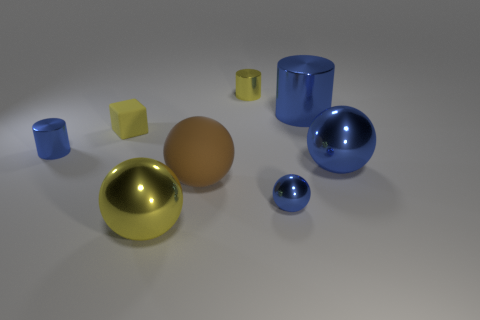Subtract all large blue spheres. How many spheres are left? 3 Subtract 1 cylinders. How many cylinders are left? 2 Subtract all yellow balls. How many balls are left? 3 Subtract all gray balls. Subtract all brown cubes. How many balls are left? 4 Add 1 spheres. How many objects exist? 9 Subtract all cylinders. How many objects are left? 5 Subtract all yellow cylinders. Subtract all yellow metal objects. How many objects are left? 5 Add 5 yellow rubber blocks. How many yellow rubber blocks are left? 6 Add 6 blue spheres. How many blue spheres exist? 8 Subtract 0 purple cubes. How many objects are left? 8 